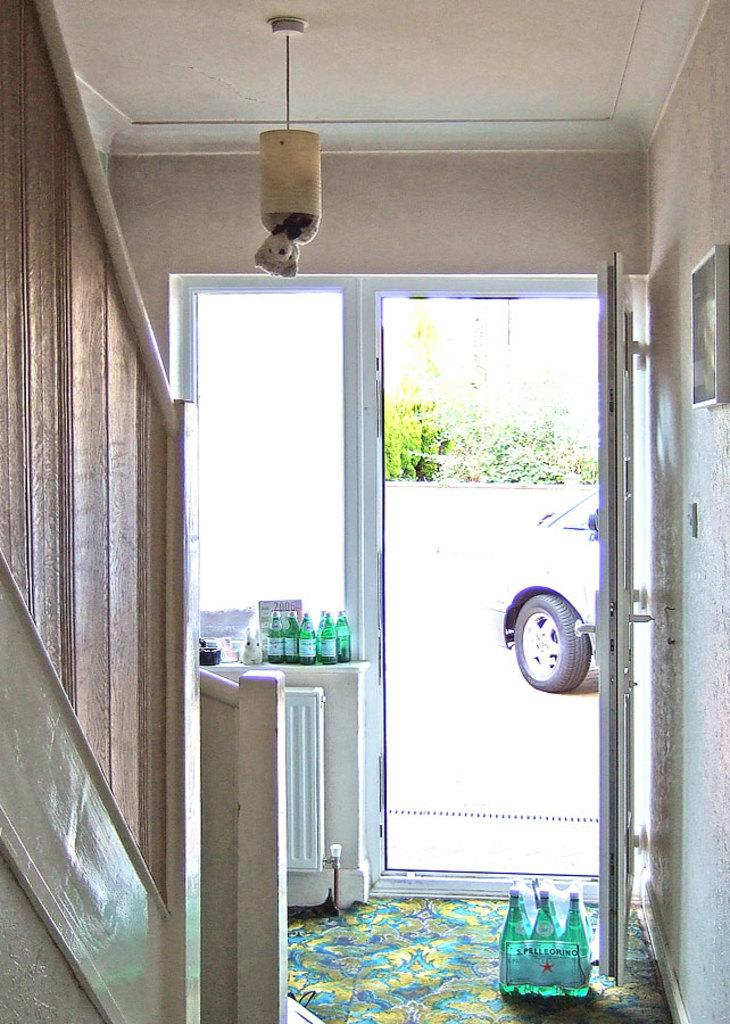What type of structure is present in the image? There is a building in the image. What objects are on the floor in the image? There are bottles on the floor in the image. What piece of furniture is present in the image? There is a table in the image. What can be seen outside the building in the image? There is a car visible outside the building in the image. What grade does the head of the building approve in the image? There is no indication in the image of a head or any grades or approval processes. 